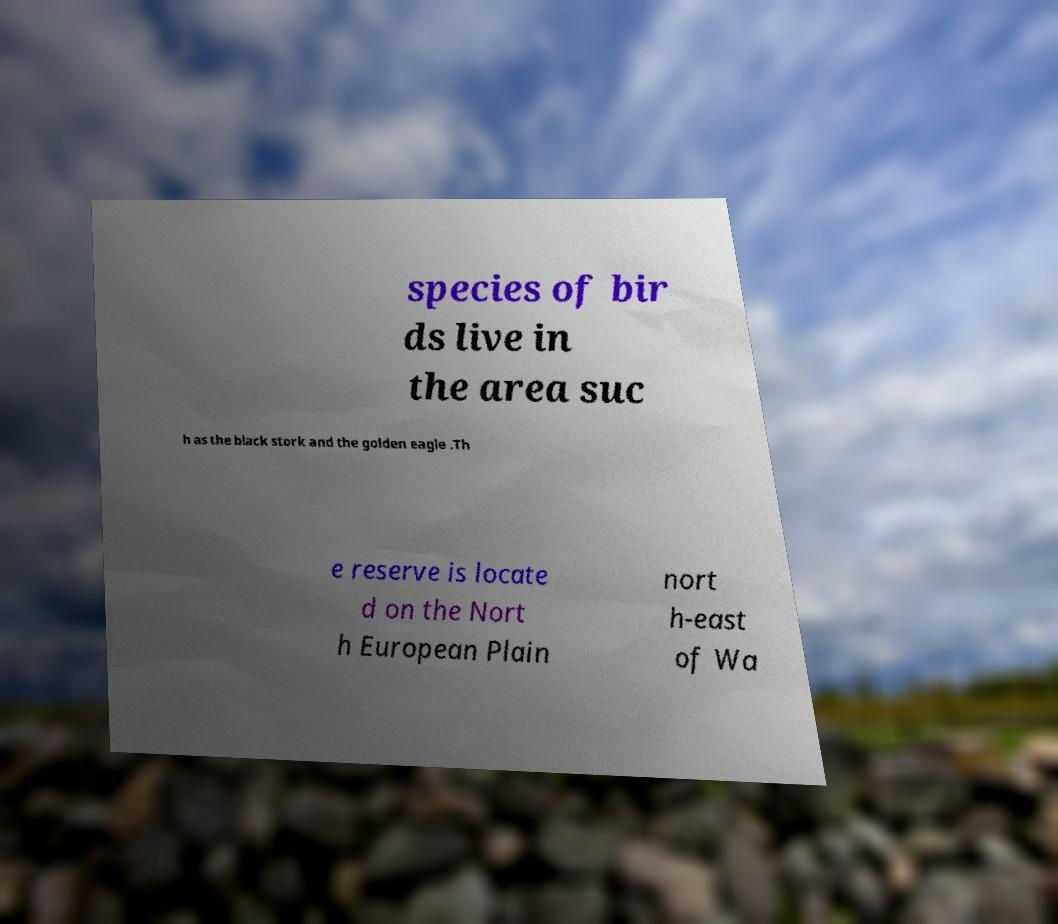There's text embedded in this image that I need extracted. Can you transcribe it verbatim? species of bir ds live in the area suc h as the black stork and the golden eagle .Th e reserve is locate d on the Nort h European Plain nort h-east of Wa 